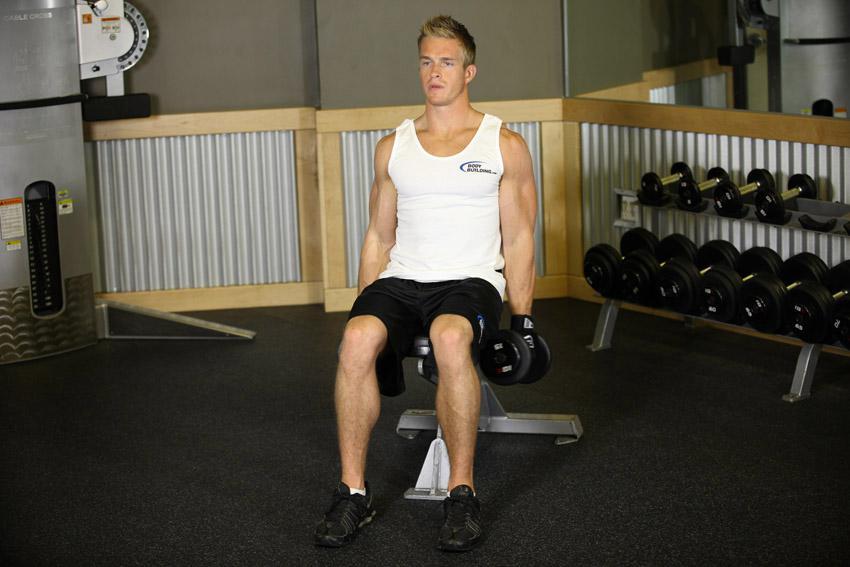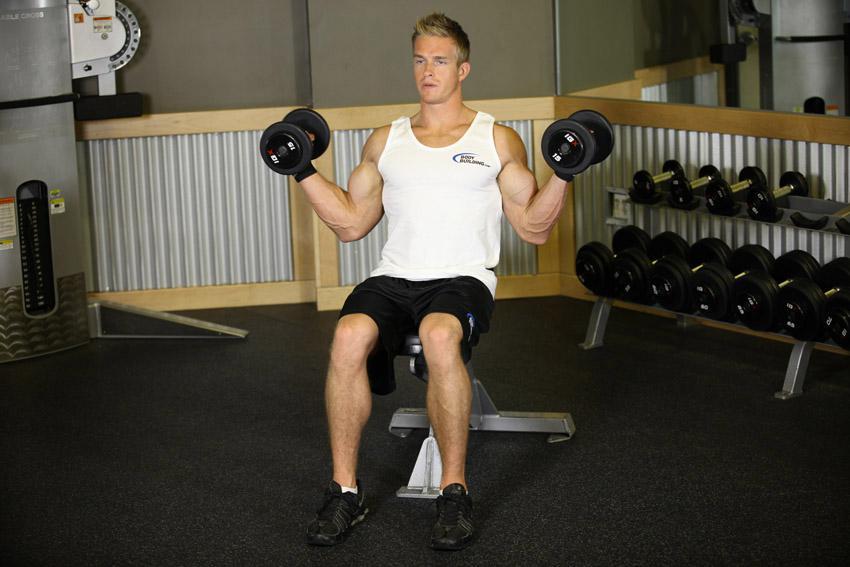The first image is the image on the left, the second image is the image on the right. For the images shown, is this caption "At least one woman is featured." true? Answer yes or no. No. 